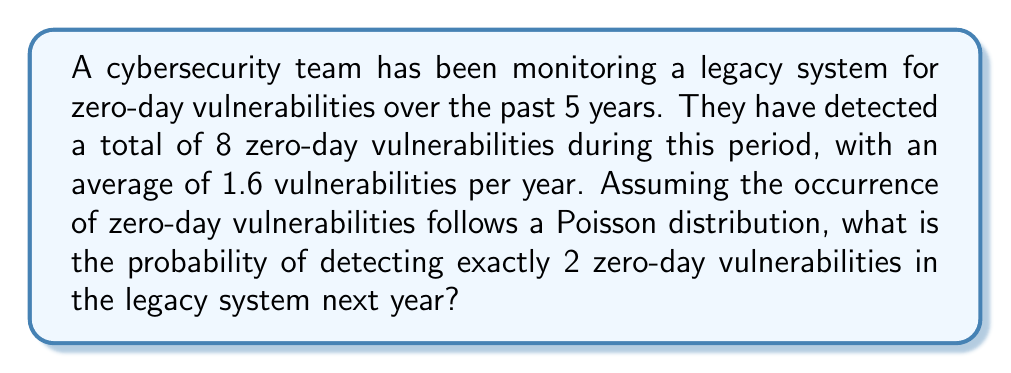Give your solution to this math problem. To solve this problem, we need to use the Poisson distribution formula. The Poisson distribution is often used to model the number of events occurring in a fixed interval of time when these events happen with a known average rate.

Given:
- The average rate (λ) of zero-day vulnerabilities per year is 1.6
- We want to calculate the probability of exactly 2 vulnerabilities (k = 2)

The Poisson probability mass function is:

$$ P(X = k) = \frac{e^{-λ} λ^k}{k!} $$

Where:
- e is the base of natural logarithms (approximately 2.71828)
- λ is the average rate of occurrences
- k is the number of occurrences we're interested in
- k! is the factorial of k

Let's plug in our values:

$$ P(X = 2) = \frac{e^{-1.6} (1.6)^2}{2!} $$

Step 1: Calculate $e^{-1.6}$
$e^{-1.6} ≈ 0.2019$

Step 2: Calculate $(1.6)^2$
$(1.6)^2 = 2.56$

Step 3: Calculate 2!
$2! = 2 × 1 = 2$

Step 4: Put it all together
$$ P(X = 2) = \frac{0.2019 × 2.56}{2} ≈ 0.2585 $$

Therefore, the probability of detecting exactly 2 zero-day vulnerabilities in the legacy system next year is approximately 0.2585 or 25.85%.
Answer: The probability of detecting exactly 2 zero-day vulnerabilities in the legacy system next year is approximately 0.2585 or 25.85%. 